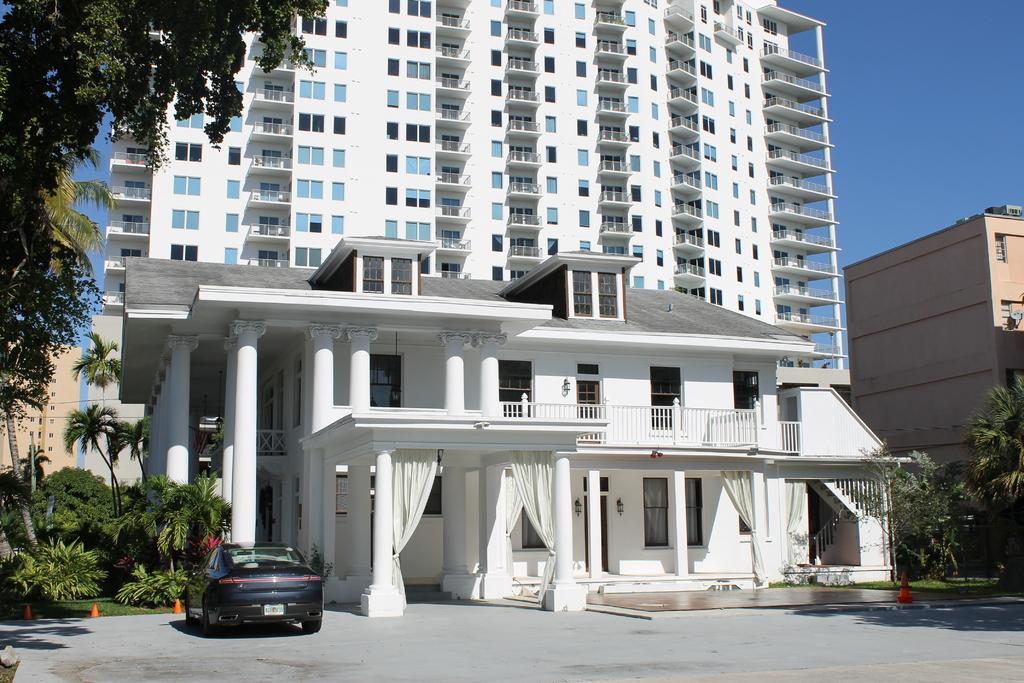Could you give a brief overview of what you see in this image? In this image I can see the vehicle in black color, few trees in green color. In the background I can see few buildings in white and cream color and the sky is in blue color. 